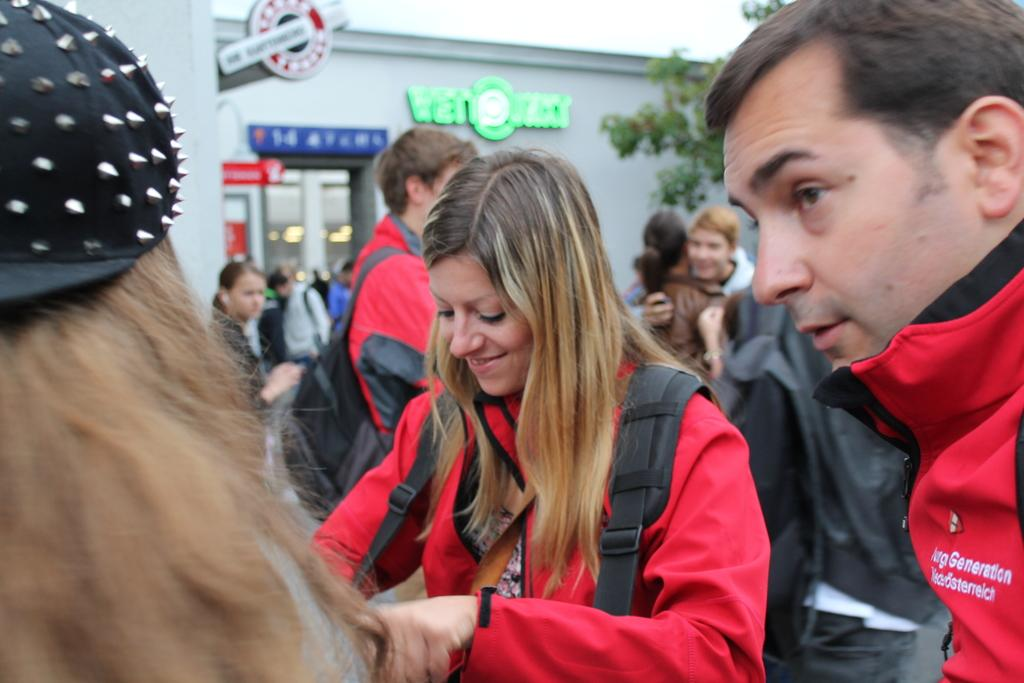How many people are in the group visible in the image? There is a group of people in the image, but the exact number cannot be determined from the provided facts. What type of structure is present in the image? There is a building in the image. What type of plant is in the image? There is a tree in the image. What type of finger can be seen in the image? There is no finger present in the image. Can you tell me how much heat is being generated by the people in the image? The provided facts do not mention any information about heat generation by the people in the image. 